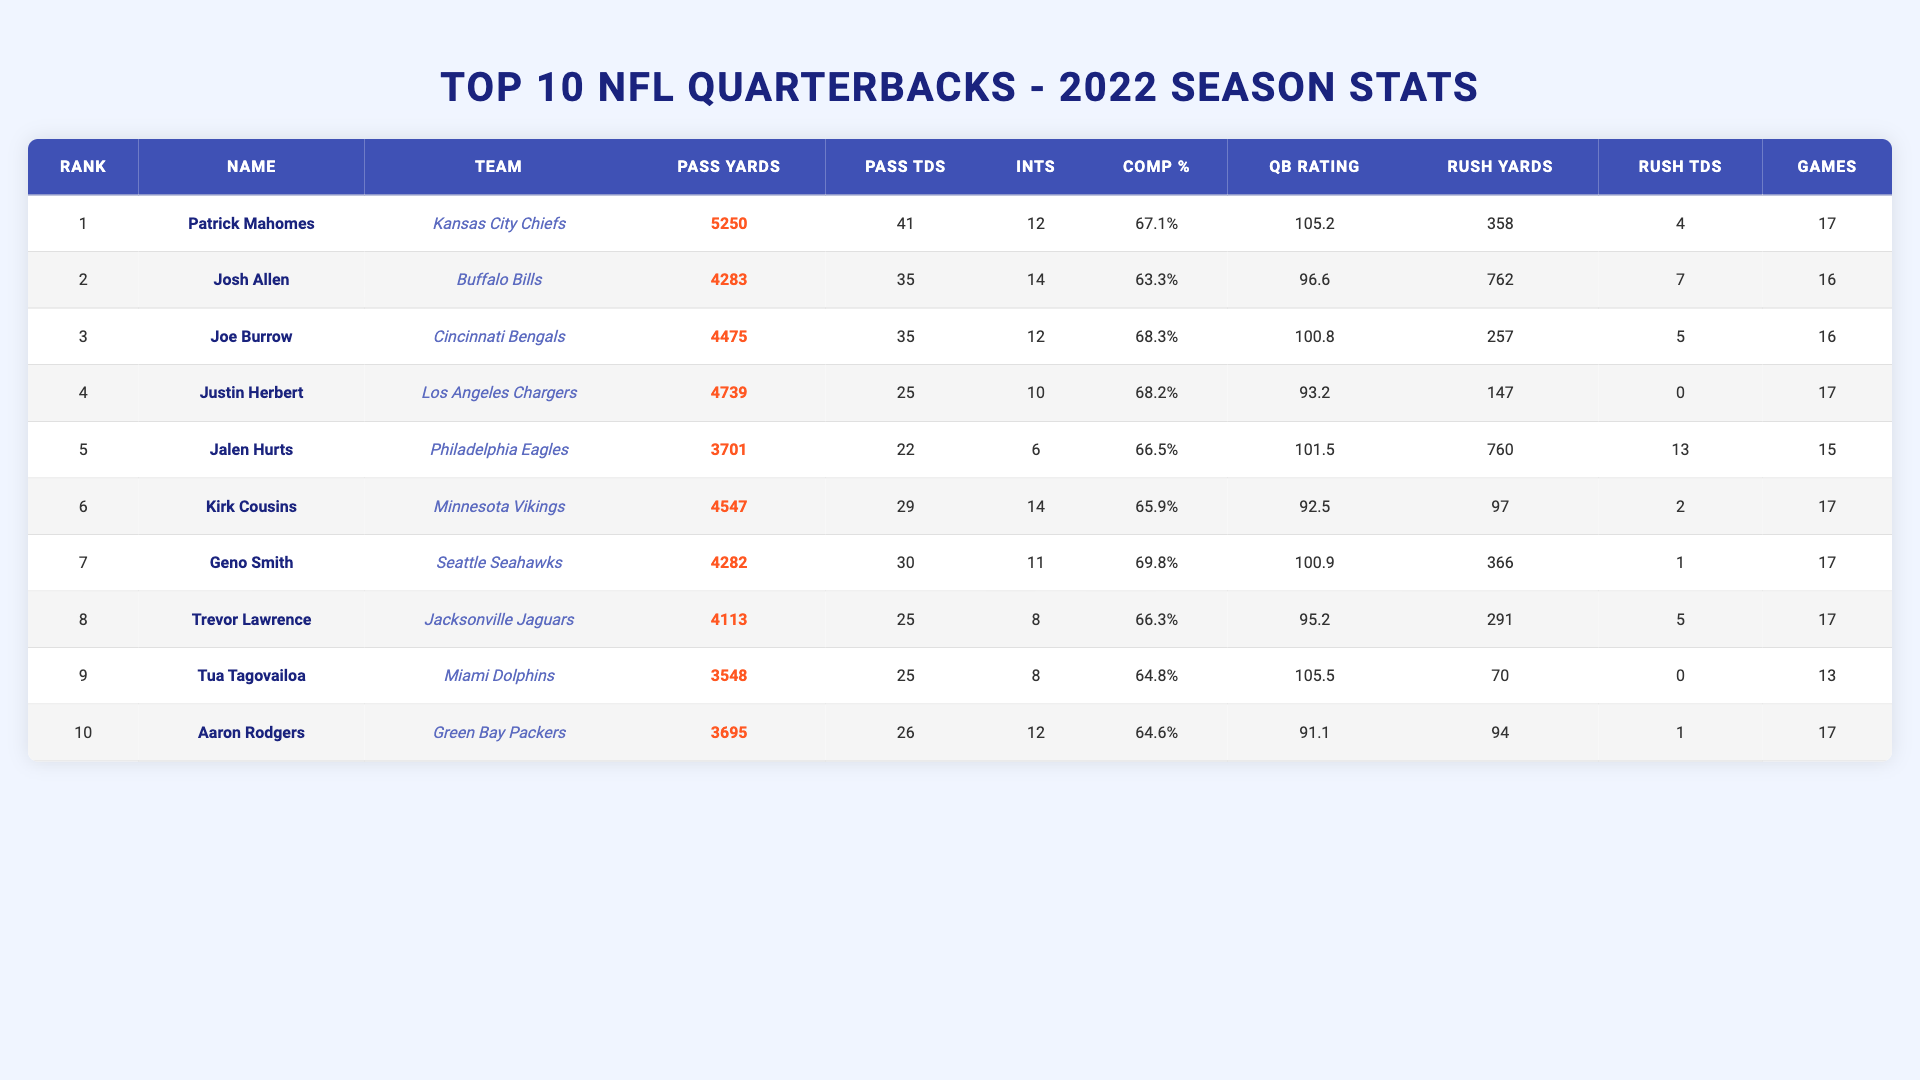What is the highest number of passing yards among the quarterbacks? Patrick Mahomes has the highest passing yards at 5250, which can be found directly by looking at the "Pass Yards" column.
Answer: 5250 Which quarterback has the most rushing touchdowns? Jalen Hurts has the most rushing touchdowns, with a total of 13, as indicated in the "Rush TDs" column.
Answer: 13 How many touchdowns did Justin Herbert throw in the 2022 season? Justin Herbert threw 25 touchdowns, which can be verified by checking the "Pass TDs" column for his entry.
Answer: 25 What is the average completion percentage of all ten quarterbacks? To calculate the average, sum the completion percentages: (67.1 + 63.3 + 68.3 + 68.2 + 66.5 + 65.9 + 69.8 + 66.3 + 64.8 + 64.6) = 685.4. There are 10 quarterbacks, so the average is 685.4 / 10 = 68.54%.
Answer: 68.54% Did any quarterback have more than 40 passing touchdowns? Only Patrick Mahomes had more than 40 passing touchdowns, specifically 41, as seen in the "Pass TDs" column.
Answer: Yes Which quarterback had the lowest QB rating? Kirk Cousins had the lowest QB rating at 92.5, which can easily be identified in the "QB Rating" column.
Answer: 92.5 What is the total number of interceptions thrown by all quarterbacks combined? Summing the interceptions gives: 12 + 14 + 12 + 10 + 6 + 14 + 11 + 8 + 8 + 12 =  117 total interceptions across all quarterbacks.
Answer: 117 How many quarterbacks played in more than 16 games? Five quarterbacks played in more than 16 games: Patrick Mahomes, Justin Herbert, Jalen Hurts, Kirk Cousins, and Geno Smith; their game counts are directly listed in the "Games" column.
Answer: 5 Which quarterback had the highest quarterback rating? Tua Tagovailoa had the highest quarterback rating at 105.5, as indicated in the "QB Rating" column.
Answer: 105.5 How many quarterbacks had more than 3000 passing yards but fewer than 4000? Six quarterbacks had between 3000 and 4000 passing yards: Jalen Hurts, Trevor Lawrence, Tua Tagovailoa, Aaron Rodgers, and others within the specified range.
Answer: 6 